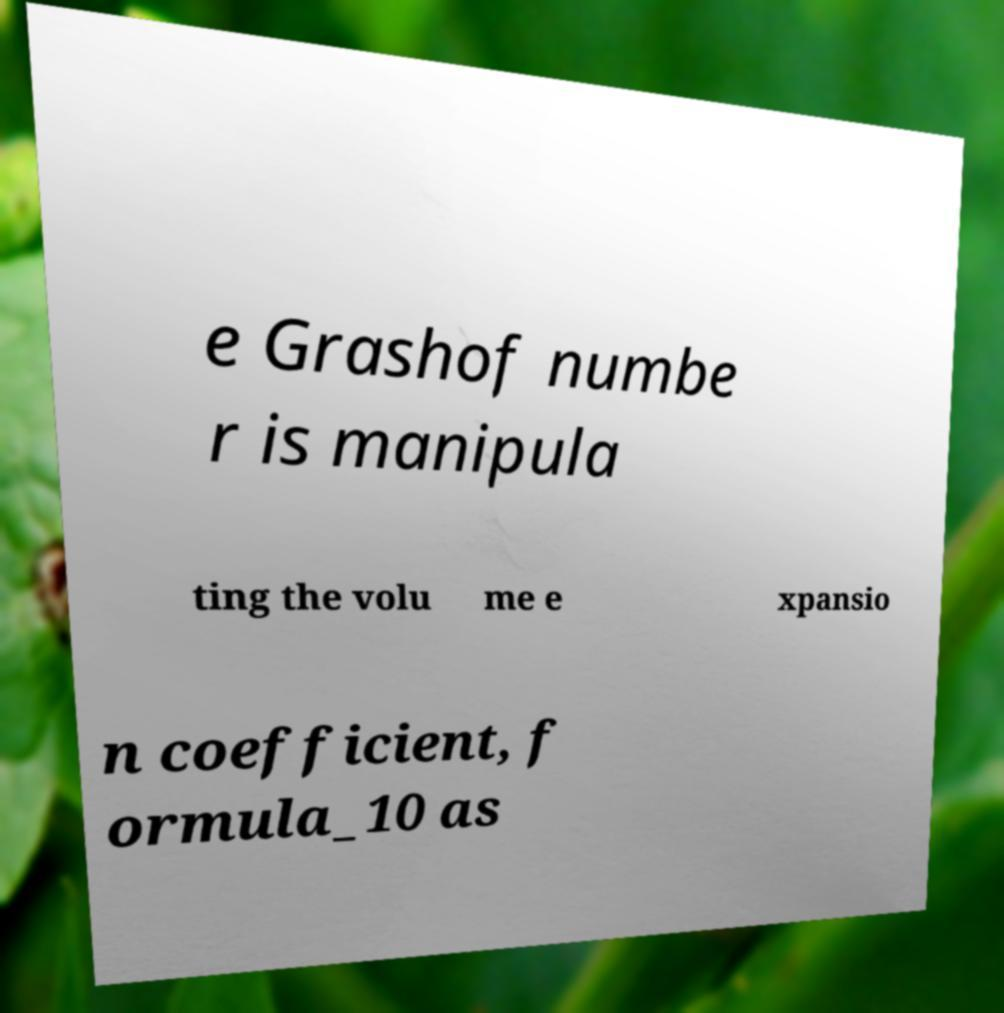What messages or text are displayed in this image? I need them in a readable, typed format. e Grashof numbe r is manipula ting the volu me e xpansio n coefficient, f ormula_10 as 